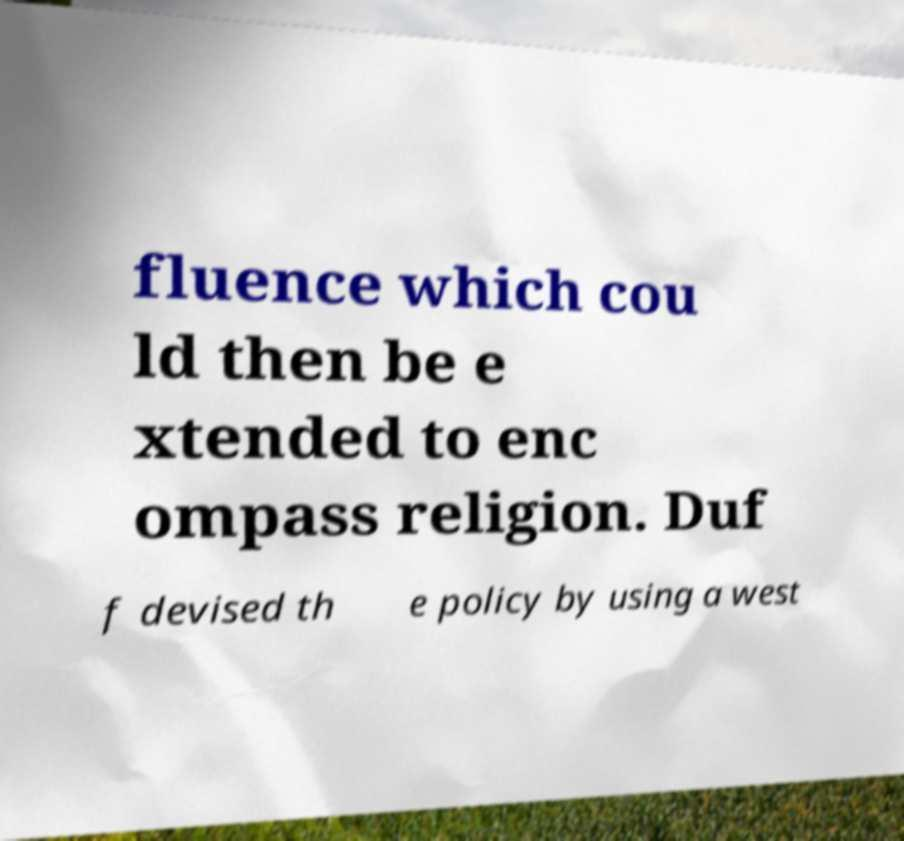There's text embedded in this image that I need extracted. Can you transcribe it verbatim? fluence which cou ld then be e xtended to enc ompass religion. Duf f devised th e policy by using a west 